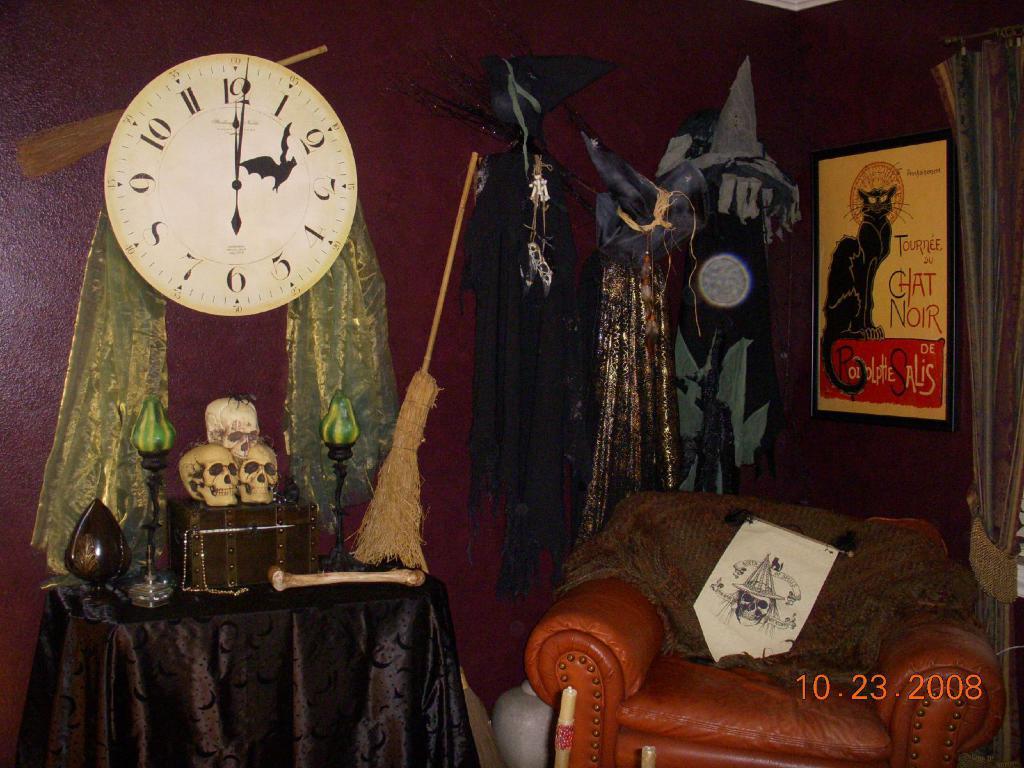What does the poster with the cat say on it?
Provide a short and direct response. Unanswerable. 